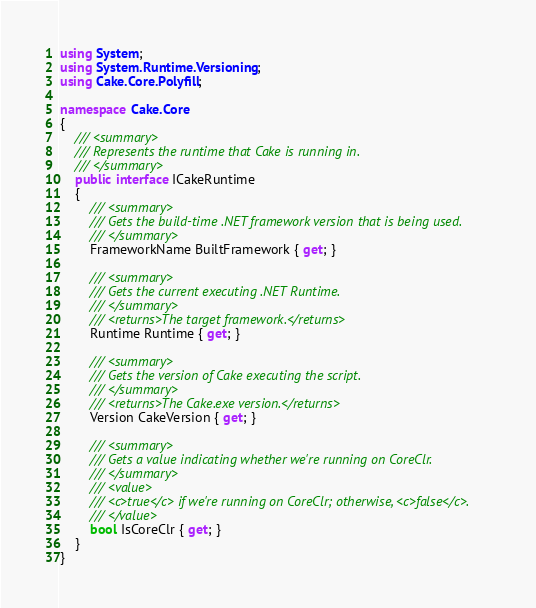Convert code to text. <code><loc_0><loc_0><loc_500><loc_500><_C#_>
using System;
using System.Runtime.Versioning;
using Cake.Core.Polyfill;

namespace Cake.Core
{
    /// <summary>
    /// Represents the runtime that Cake is running in.
    /// </summary>
    public interface ICakeRuntime
    {
        /// <summary>
        /// Gets the build-time .NET framework version that is being used.
        /// </summary>
        FrameworkName BuiltFramework { get; }

        /// <summary>
        /// Gets the current executing .NET Runtime.
        /// </summary>
        /// <returns>The target framework.</returns>
        Runtime Runtime { get; }

        /// <summary>
        /// Gets the version of Cake executing the script.
        /// </summary>
        /// <returns>The Cake.exe version.</returns>
        Version CakeVersion { get; }

        /// <summary>
        /// Gets a value indicating whether we're running on CoreClr.
        /// </summary>
        /// <value>
        /// <c>true</c> if we're running on CoreClr; otherwise, <c>false</c>.
        /// </value>
        bool IsCoreClr { get; }
    }
}</code> 